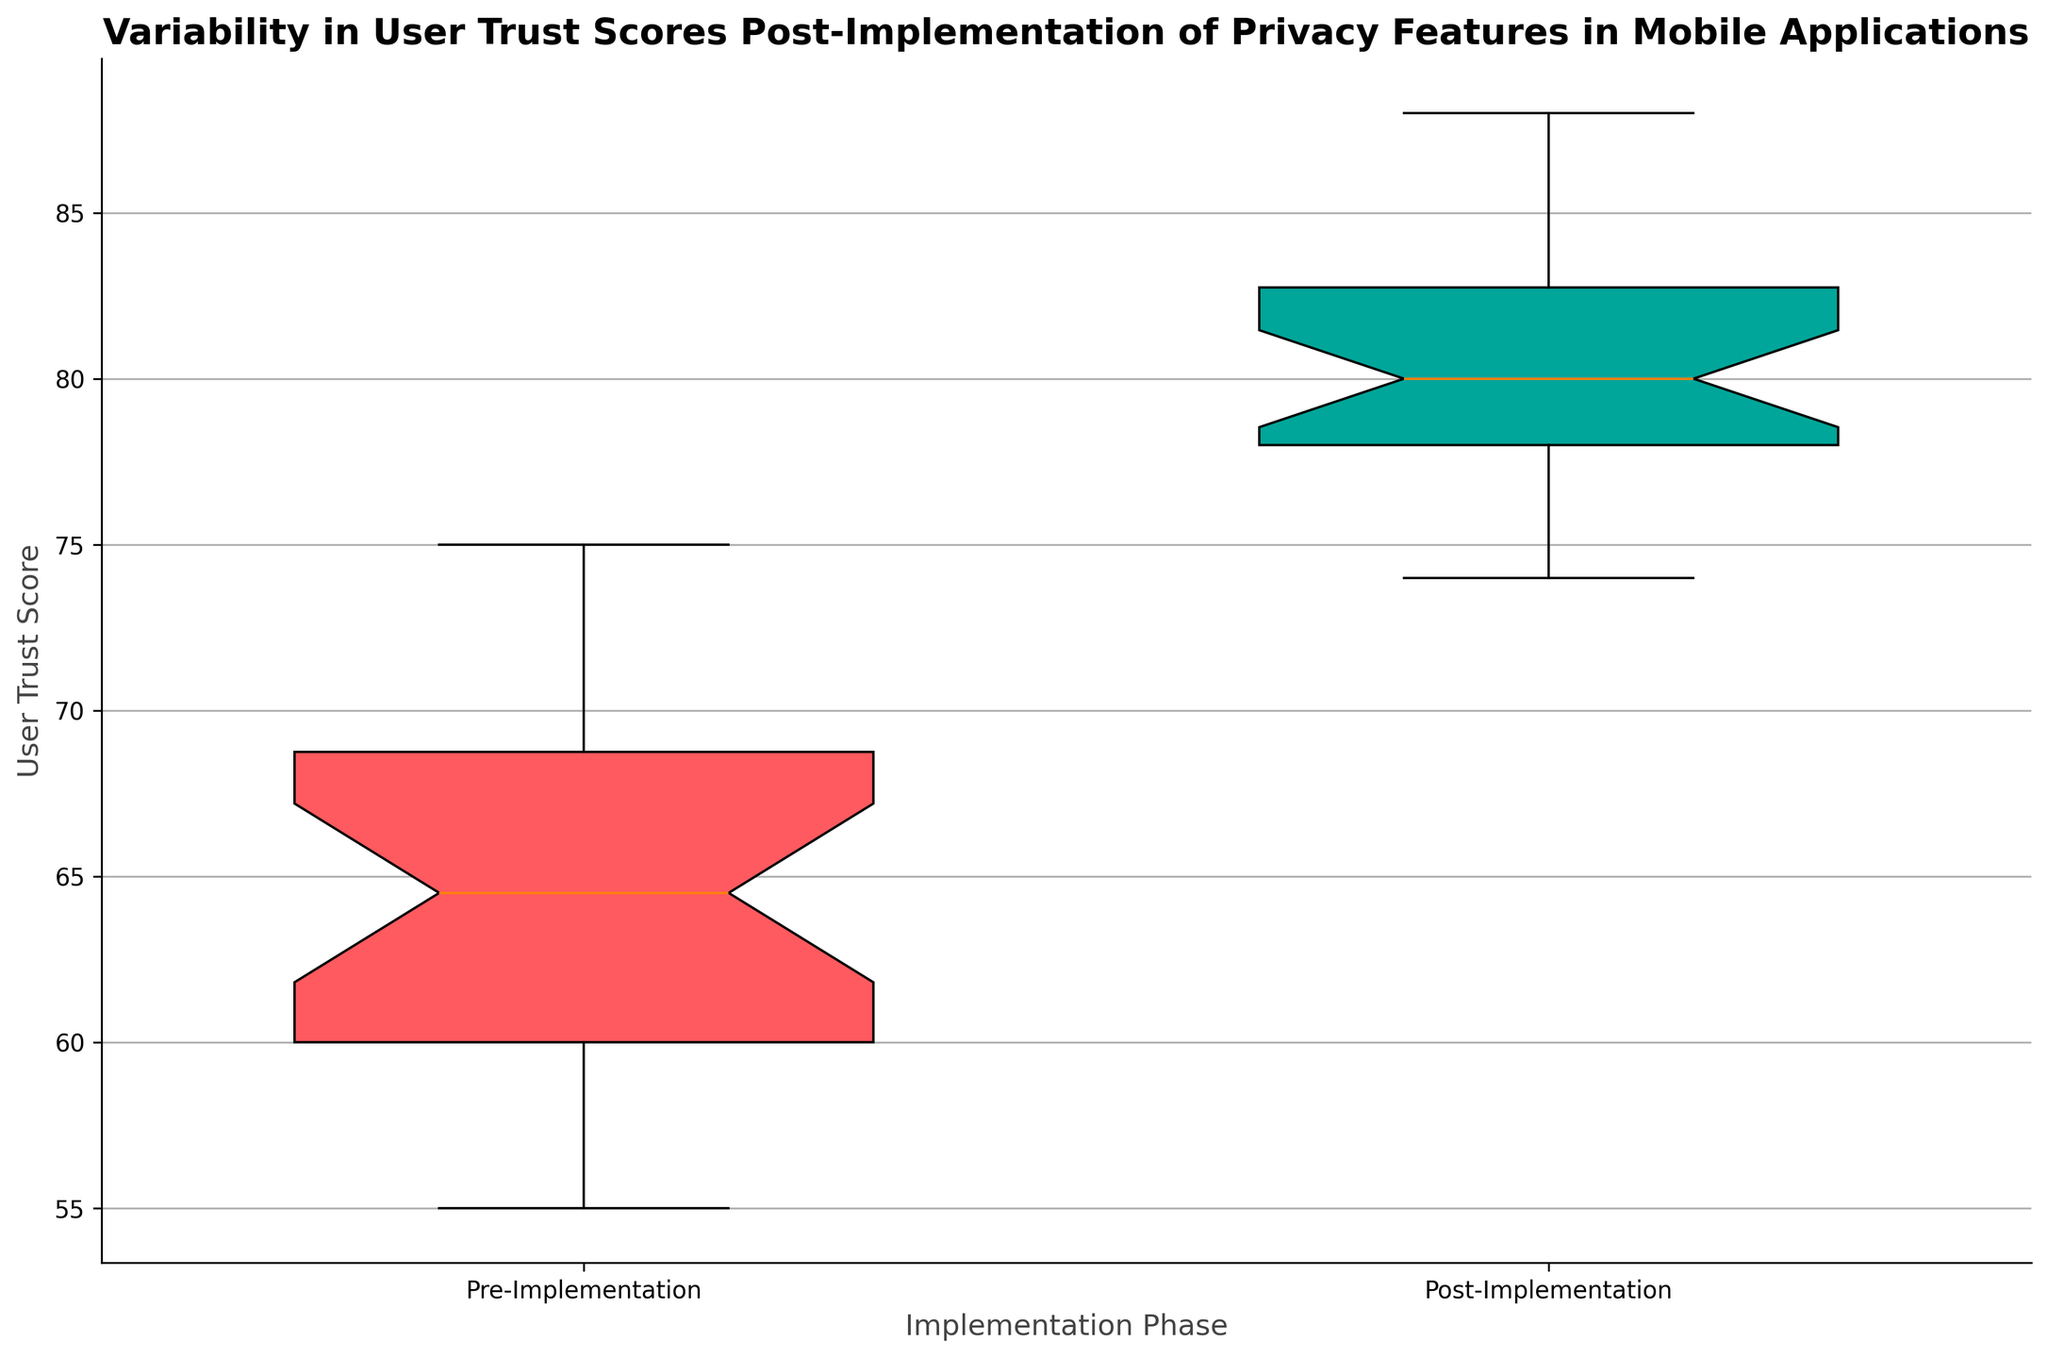What is the median user trust score post-implementation? The box plot has a line inside the box which indicates the median value. For the post-implementation group, we observe that this line is positioned around 81.
Answer: 81 How does the interquartile range (IQR) compare between pre-implementation and post-implementation trust scores? The IQR is the difference between the first quartile (Q1) and the third quartile (Q3) in the box plot. From the figure, we see the box height (vertical distance) of the post-implementation group is smaller compared to the pre-implementation group, indicating a smaller IQR post-implementation.
Answer: Post-implementation IQR is smaller Which phase shows a higher overall variability in user trust scores? Overall variability can be inferred from the length of the whiskers in the box plot, which represent the range of the data excluding outliers. The pre-implementation phase has a longer range compared to the post-implementation phase.
Answer: Pre-implementation What is the difference in the median trust scores before and after implementing privacy features? The median can be observed at the lines within each box. The pre-implementation median is around 65, and the post-implementation median is around 81. The difference is calculated as 81 - 65.
Answer: 16 Which phase has the higher maximum value in user trust score? The maximum value in each phase is represented by the top whisker of the box plot. The whisker for the post-implementation phase is higher than the whisker for the pre-implementation phase.
Answer: Post-Implementation Are there any outliers in the pre-implementation trust scores? Outliers in a box plot are represented by individual points outside the whiskers. Observing the figure, we see that there are no points outside the whiskers in the pre-implementation phase.
Answer: No What color represents the post-implementation trust scores in the box plot? The post-implementation box plot is colored differently than the pre-implementation plot. For the post-implementation group, the color used is green.
Answer: Green Comparing the medians, how much improvement is seen in the user trust scores post-implementation? The pre-implementation median is approximately 65, and the post-implementation median is approximately 81. The improvement can be calculated by finding the difference: 81 - 65.
Answer: 16 What is the range of user trust scores post-implementation? The range is given by the difference between the maximum and minimum whisker values. For post-implementation trust scores, this is approximately from 74 to 88. Calculating this gives 88 - 74.
Answer: 14 Which implementation phase shows a higher third quartile value? The third quartile (Q3) is represented by the top boundary of each box. Upon observing the plot, the third quartile for post-implementation is higher compared to the pre-implementation phase.
Answer: Post-Implementation 